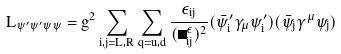<formula> <loc_0><loc_0><loc_500><loc_500>L _ { \psi ^ { \prime } \psi ^ { \prime } \psi \psi } = g ^ { 2 } \sum _ { i , j = L , R } \sum _ { q = u , d } \frac { \epsilon _ { i j } } { ( \Lambda _ { i j } ^ { \epsilon } ) ^ { 2 } } ( \bar { \psi } _ { i } ^ { \prime } \gamma _ { \mu } \psi _ { i } ^ { \prime } ) ( \bar { \psi } _ { j } \gamma ^ { \mu } \psi _ { j } )</formula> 